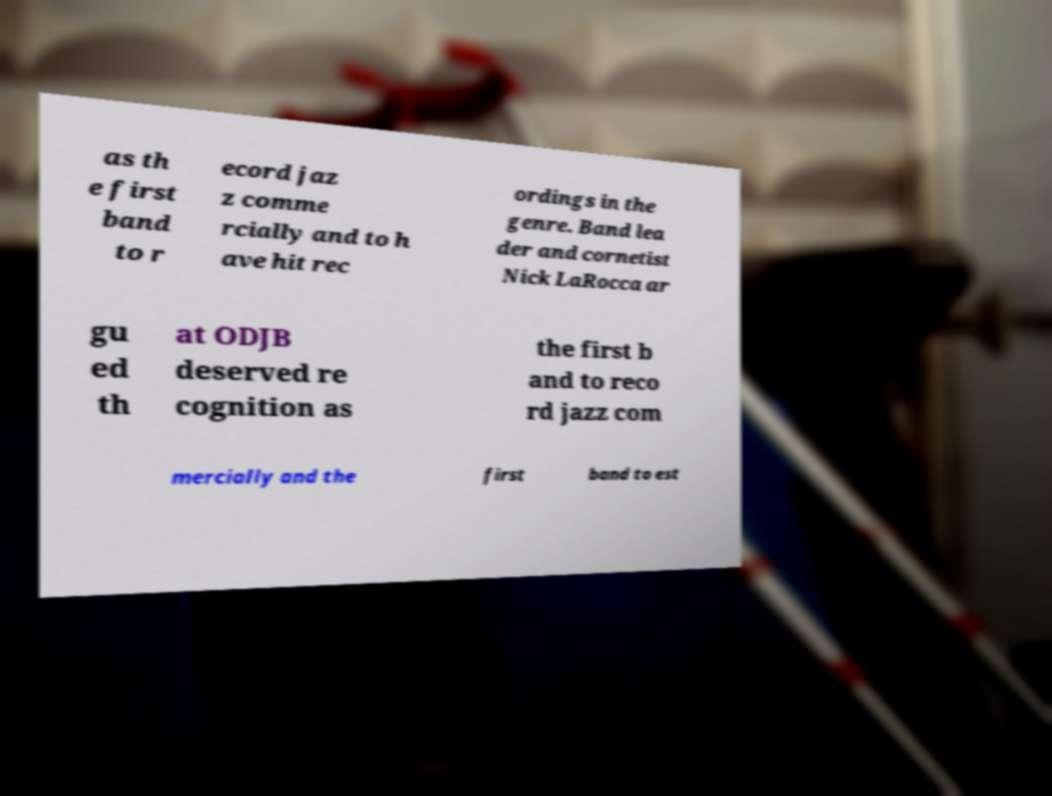Can you accurately transcribe the text from the provided image for me? as th e first band to r ecord jaz z comme rcially and to h ave hit rec ordings in the genre. Band lea der and cornetist Nick LaRocca ar gu ed th at ODJB deserved re cognition as the first b and to reco rd jazz com mercially and the first band to est 